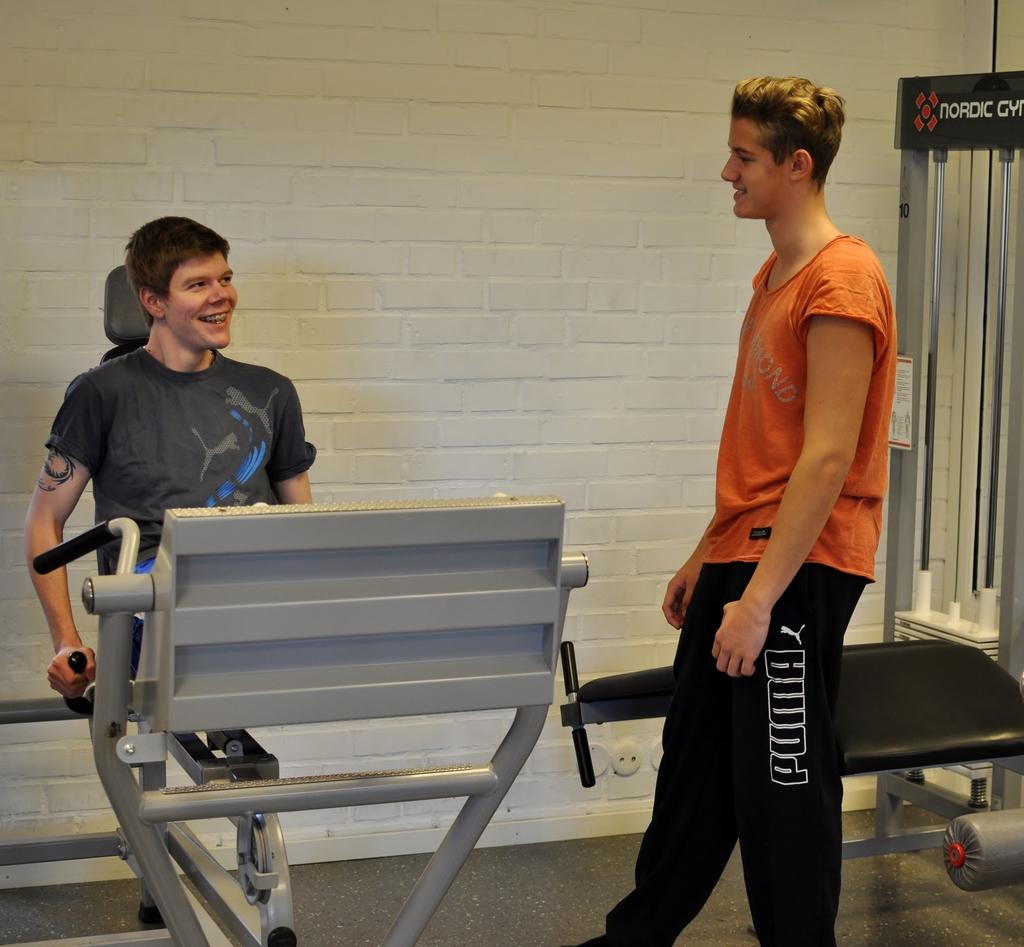What is the position of the man in the image? There is a man standing in the image. What is the man standing on? The man is standing on a floor. What is the other man in the image doing? The other man is sitting in the image and using a workout machine. What can be seen in the background of the image? There is a wall in the background of the image. What type of house is depicted in the image? There is no house depicted in the image; it features two men, one standing and one sitting on a workout machine. How does the society influence the workout routine of the man sitting on the machine? The image does not provide any information about the influence of society on the man's workout routine. 